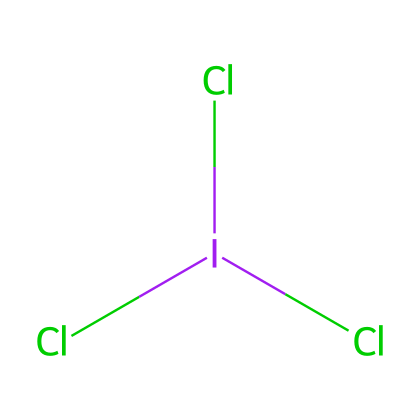How many chlorine atoms are present in iodine trichloride? The chemical structure Cl[I](Cl)Cl indicates the presence of three chlorine atoms attached to the iodine atom. Each 'Cl' in the SMILES representation represents a chlorine atom.
Answer: three What is the central atom in this molecule? In the provided SMILES, iodine (I) is depicted in the center, surrounded by chlorine (Cl) atoms, making it the central atom of the molecule.
Answer: iodine Is iodine trichloride a hypervalent compound? A hypervalent compound is characterized by a central atom that has more than eight electrons in its valence shell. Iodine in this compound is bonded to three chlorine atoms, allowing for 7 electrons around it, which does not exceed the octet. However, it’s categorized as hypervalent due to its tendency to exhibit expanded valence in different contexts.
Answer: yes How many total bonds are formed in iodine trichloride? The molecule has three Cl-I bonds, as represented in the SMILES structure with three 'Cl' connected to the central 'I', which shows three bonding interactions.
Answer: three What type of bond exists between iodine and each chlorine atom? The bonds between iodine and chlorine in this molecule are covalent bonds, as both elements share electrons to form stable connections, typical for halogen interactions.
Answer: covalent What role does iodine trichloride play in public spaces? Iodine trichloride is commonly used as a disinfectant due to its efficacy in killing bacteria and viruses, making it important for sanitizing surfaces in accessible public spaces.
Answer: disinfectant 